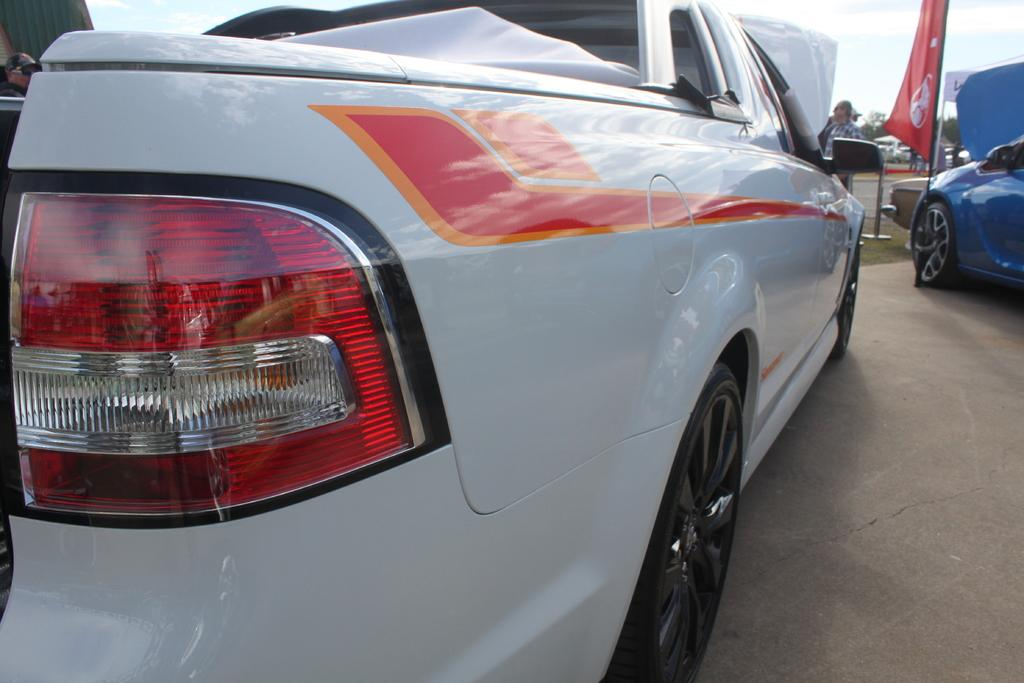What type of vehicle is in the image? There is a white car in the image. Can you describe the other vehicle in the image? There is another car in the top right of the image. What is located beside the second car? There is a flag beside the second car. What type of rock is being shaken by the crook in the image? There is no rock or crook present in the image. 